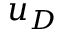<formula> <loc_0><loc_0><loc_500><loc_500>u _ { D }</formula> 